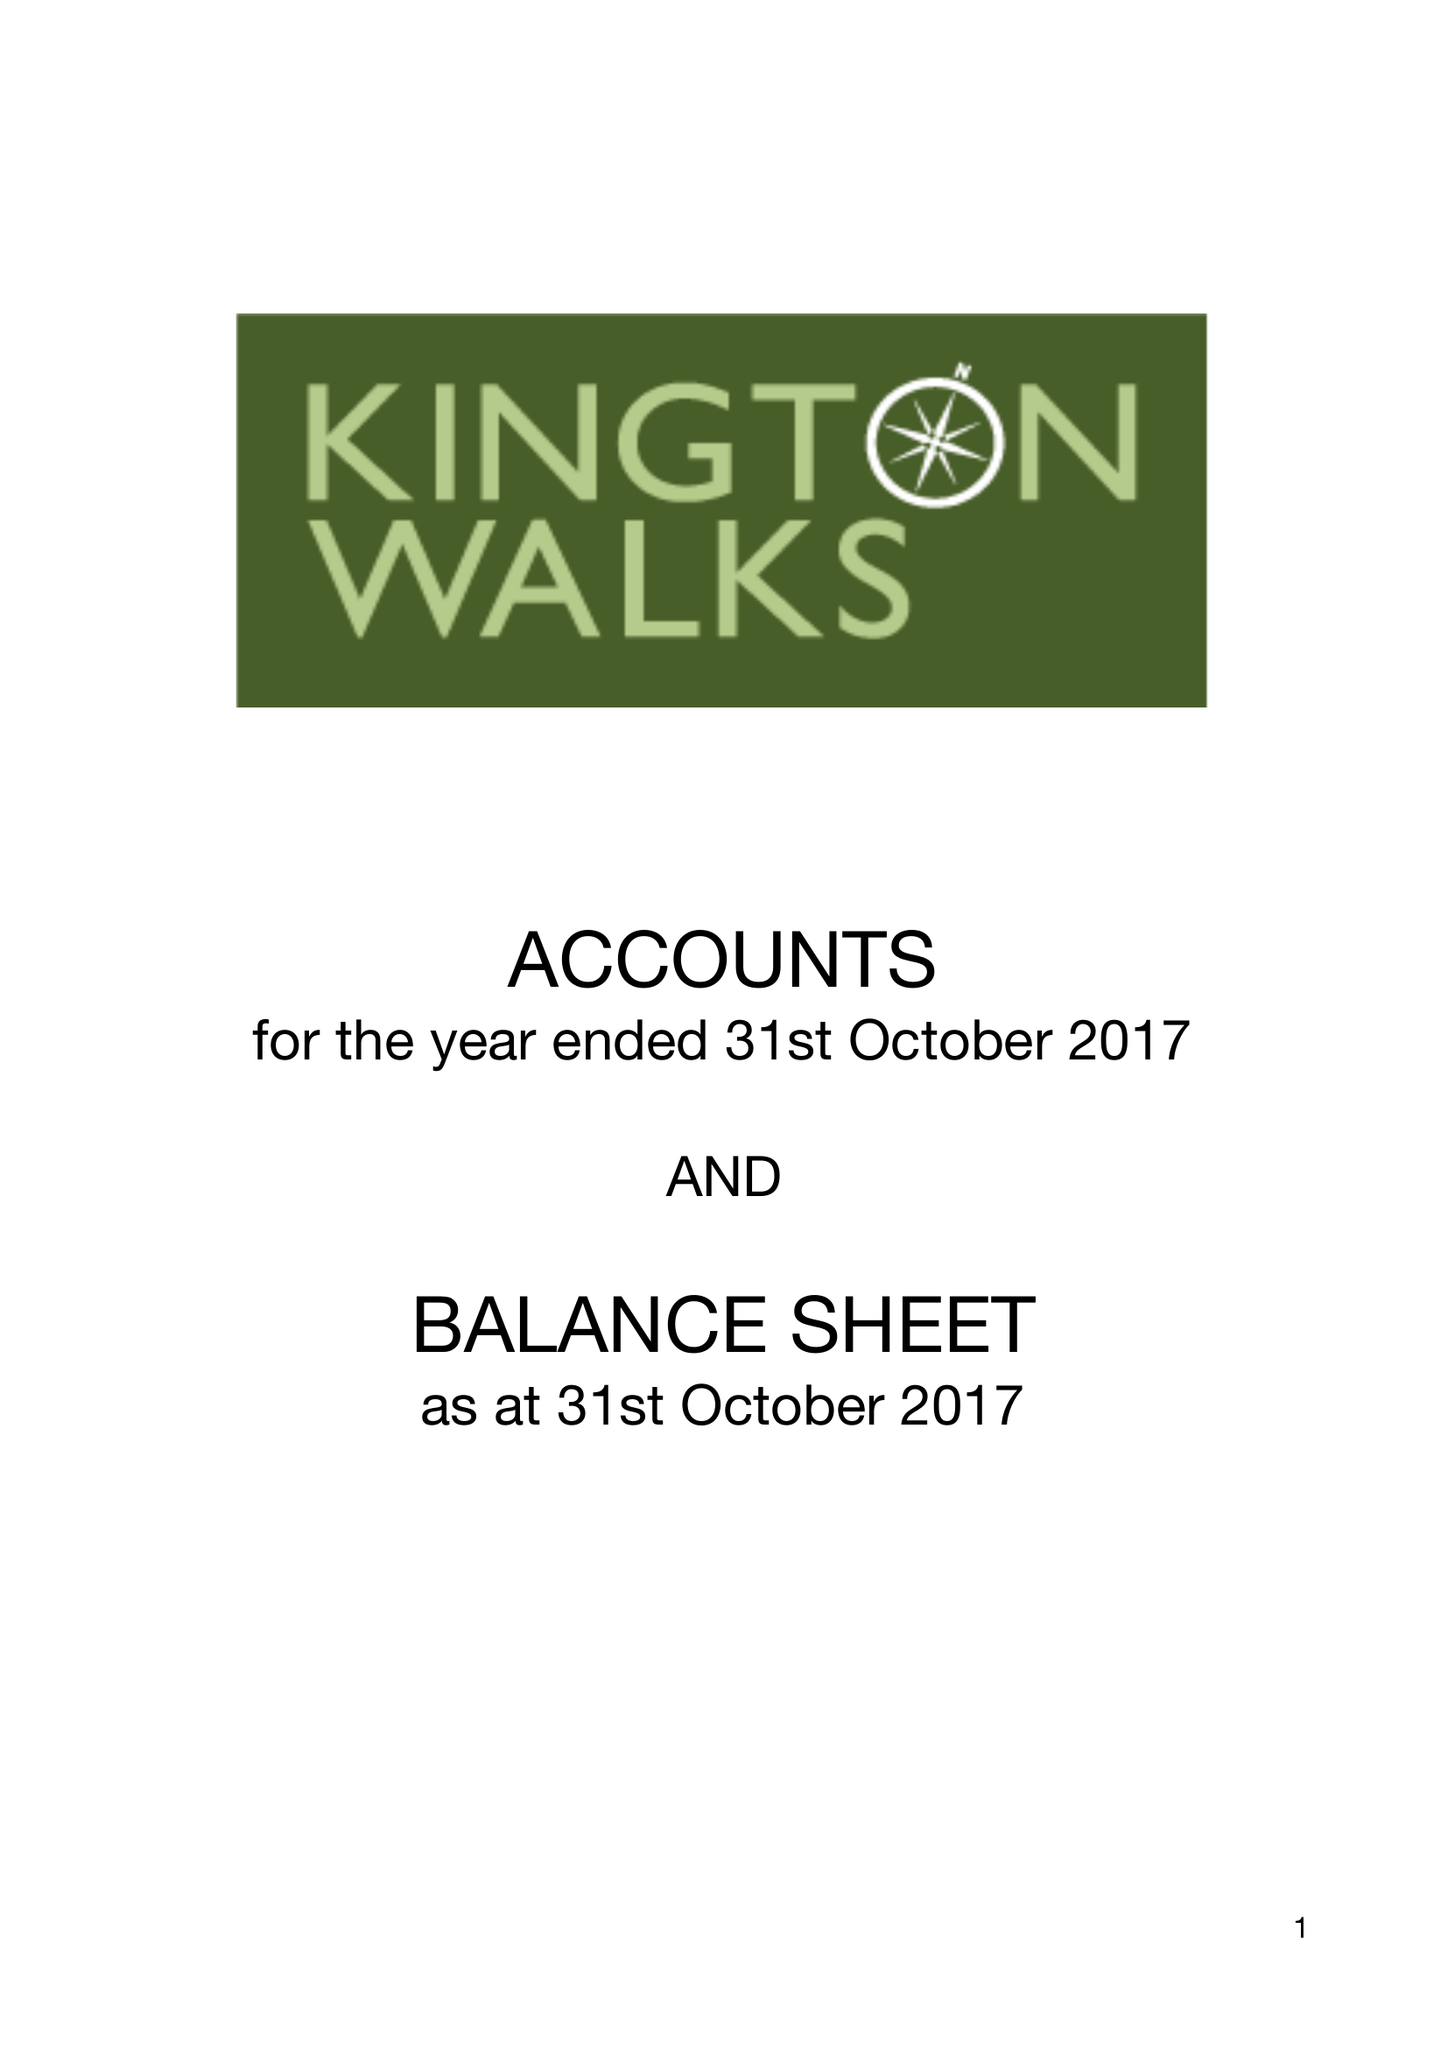What is the value for the address__street_line?
Answer the question using a single word or phrase. KINGSWOOD 